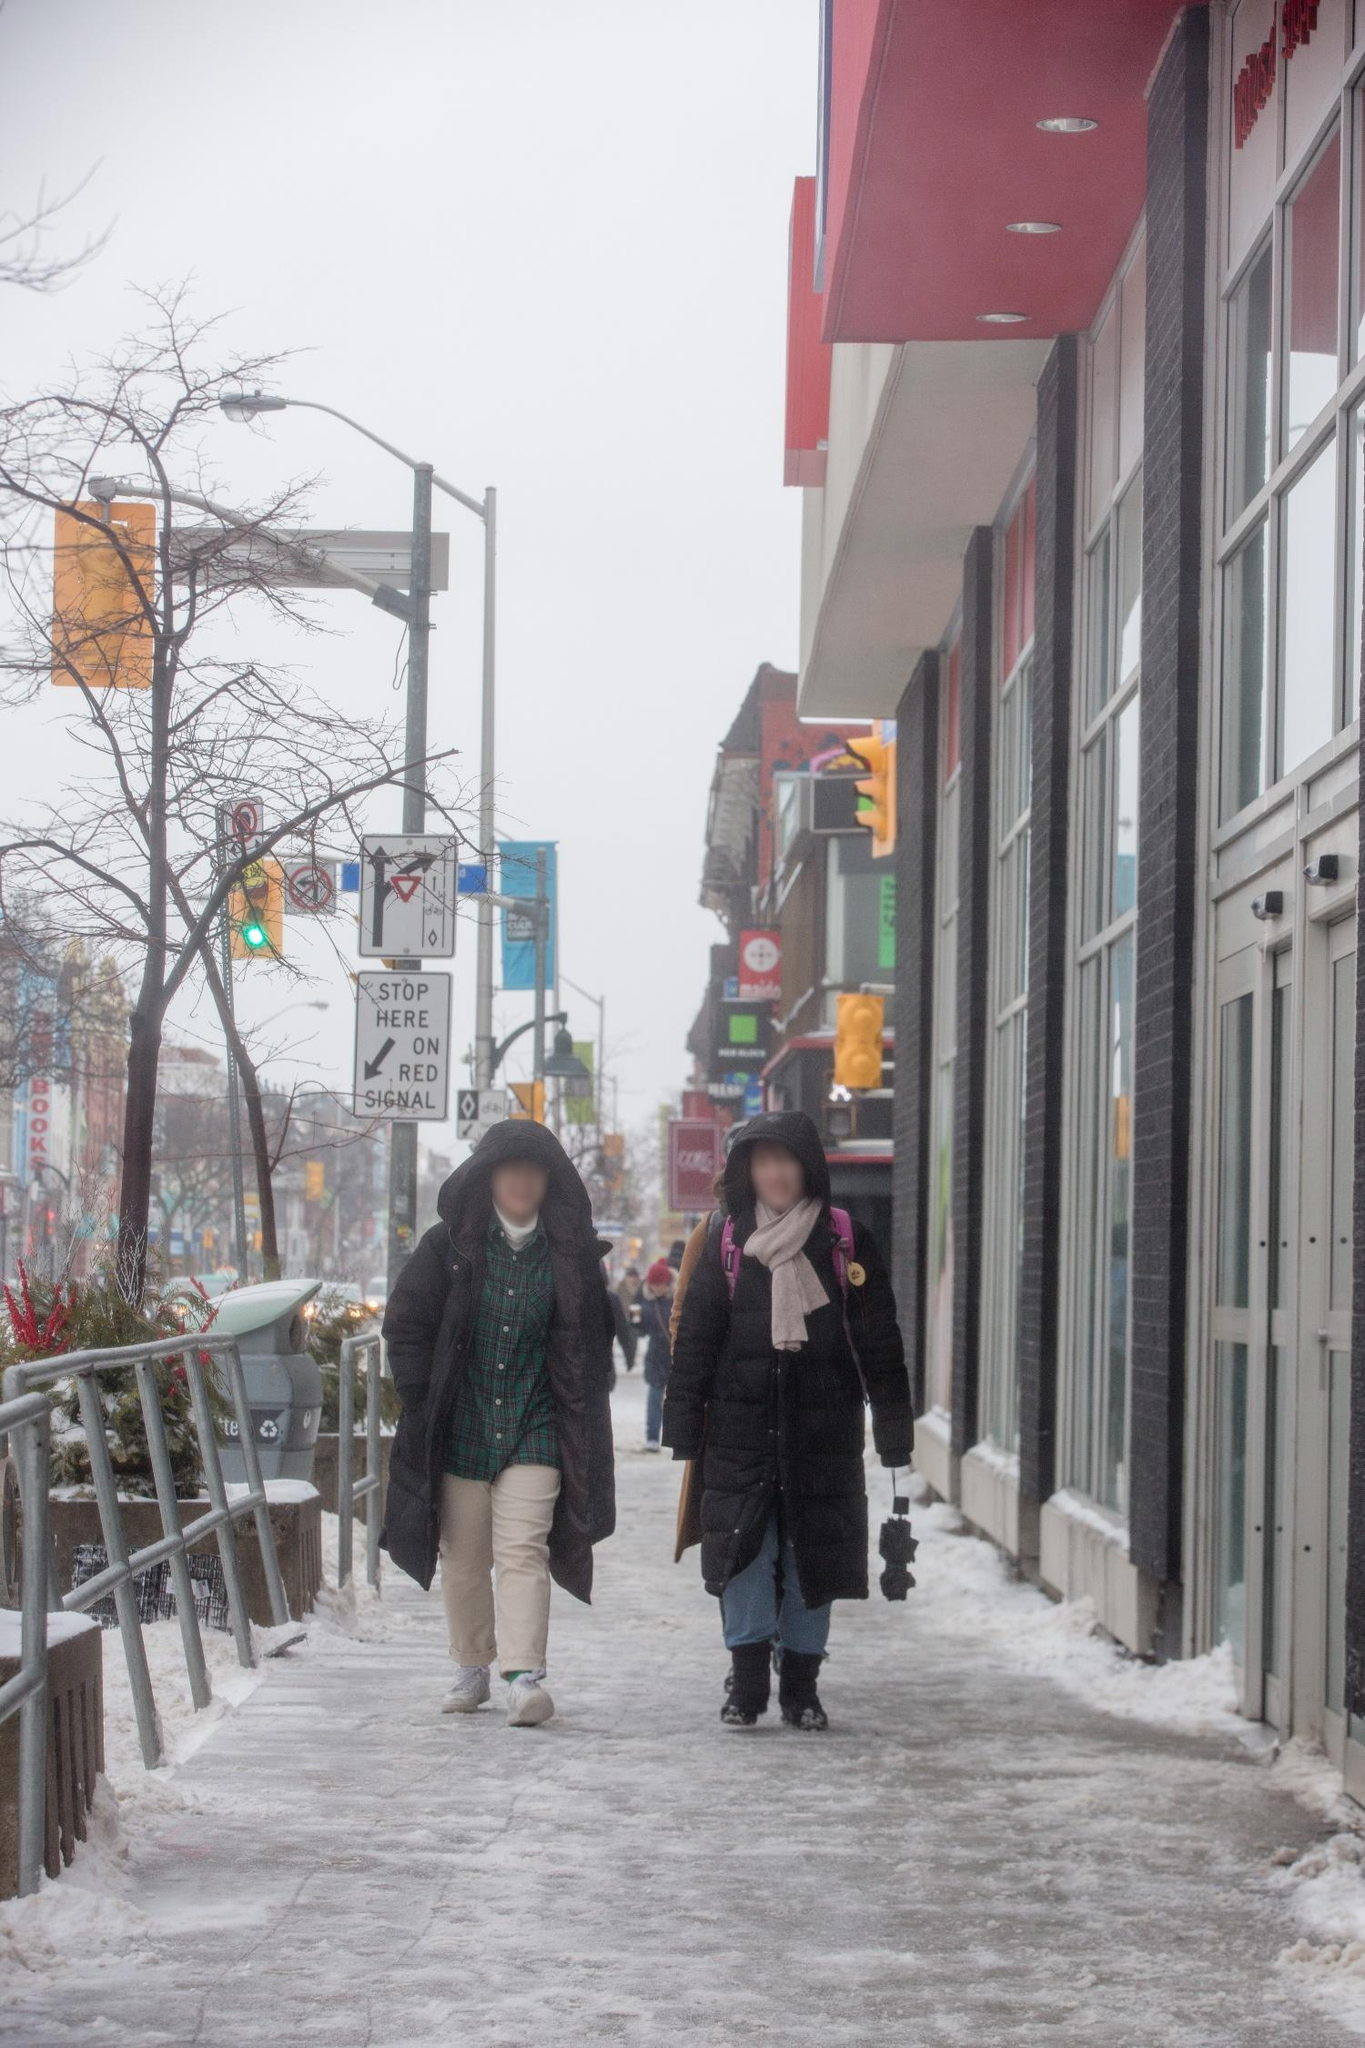What's something whimsical you can imagine happening in this scene? Imagine if, as these two friends walked down the snowy sidewalk, they suddenly discovered a secret door hidden in the wall of the red building. This door, covered in frost and unnoticed by passersby for years, leads to a magical winter wonderland, complete with ice castles, talking snowmen, and a warm, welcoming community of mythical creatures. The friends step inside and embark on a whimsical adventure, finding themselves amidst a festival of light where every snowflake tells a story and the air is filled with the sounds of laughter and magical music. 